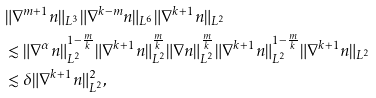Convert formula to latex. <formula><loc_0><loc_0><loc_500><loc_500>& \| \nabla ^ { m + 1 } n \| _ { L ^ { 3 } } \| \nabla ^ { k - m } n \| _ { L ^ { 6 } } \| \nabla ^ { k + 1 } n \| _ { L ^ { 2 } } \\ & \lesssim \| \nabla ^ { \alpha } n \| _ { L ^ { 2 } } ^ { 1 - \frac { m } { k } } \| \nabla ^ { k + 1 } n \| _ { L ^ { 2 } } ^ { \frac { m } { k } } \| \nabla n \| _ { L ^ { 2 } } ^ { \frac { m } { k } } \| \nabla ^ { k + 1 } n \| _ { L ^ { 2 } } ^ { 1 - \frac { m } { k } } \| \nabla ^ { k + 1 } n \| _ { L ^ { 2 } } \\ & \lesssim \delta \| \nabla ^ { k + 1 } n \| _ { L ^ { 2 } } ^ { 2 } ,</formula> 